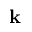Convert formula to latex. <formula><loc_0><loc_0><loc_500><loc_500>k</formula> 